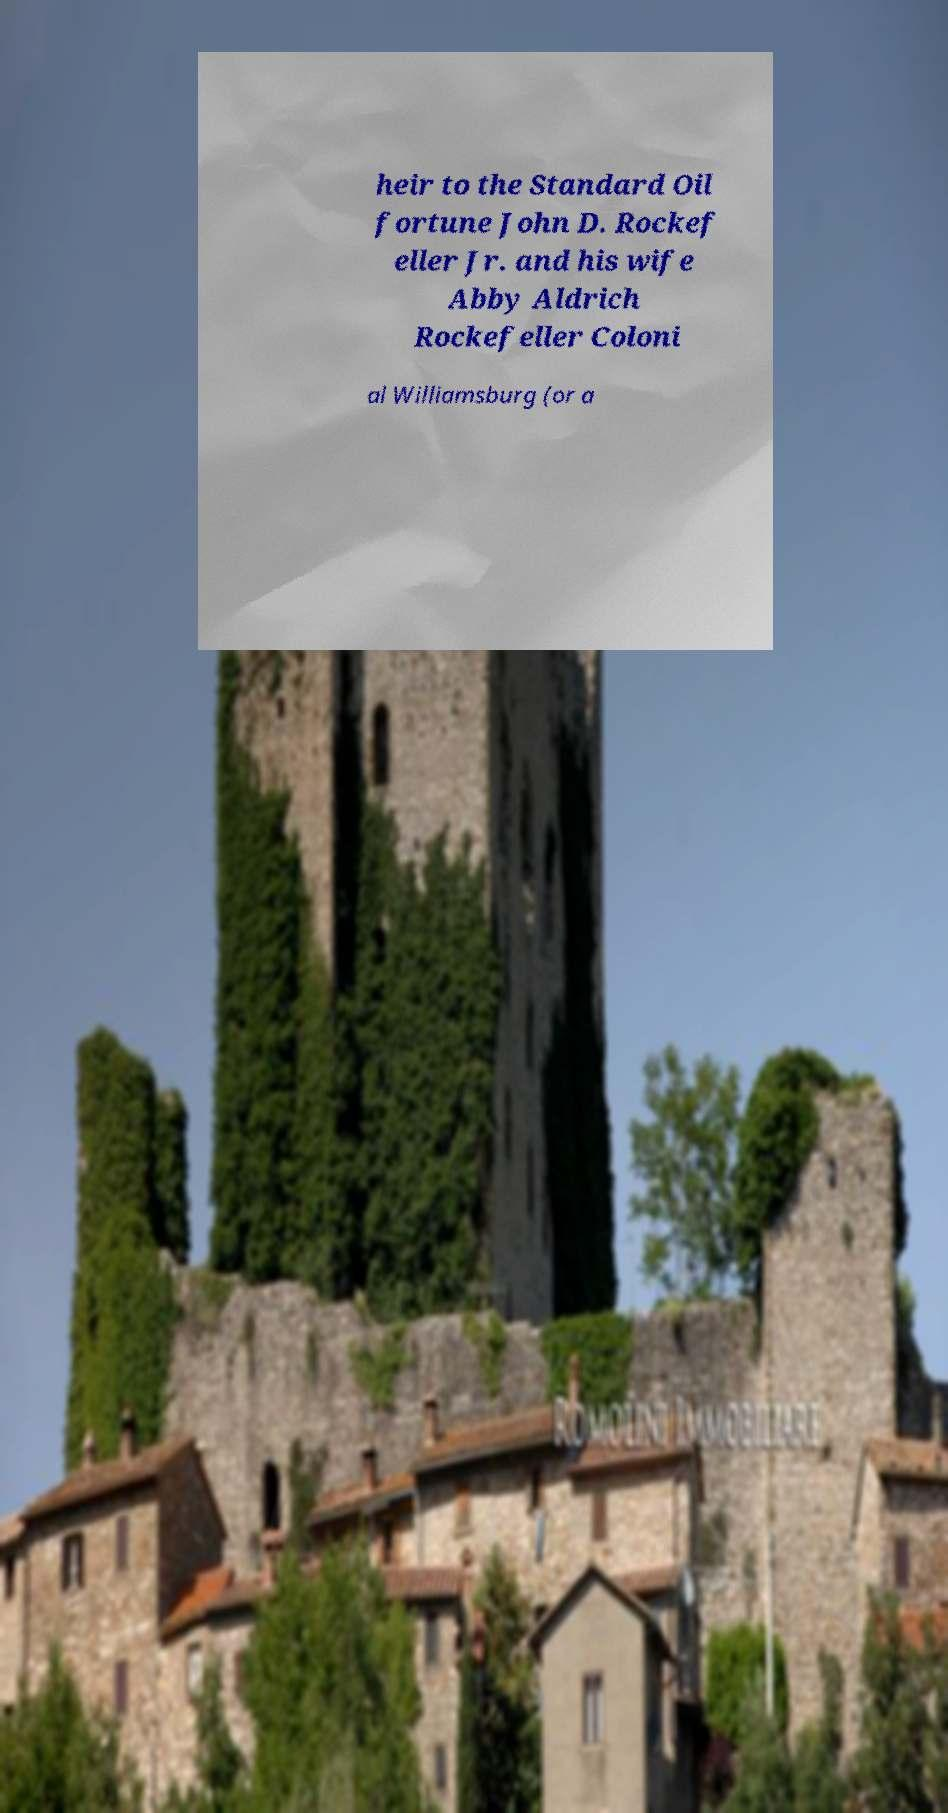Please identify and transcribe the text found in this image. heir to the Standard Oil fortune John D. Rockef eller Jr. and his wife Abby Aldrich Rockefeller Coloni al Williamsburg (or a 